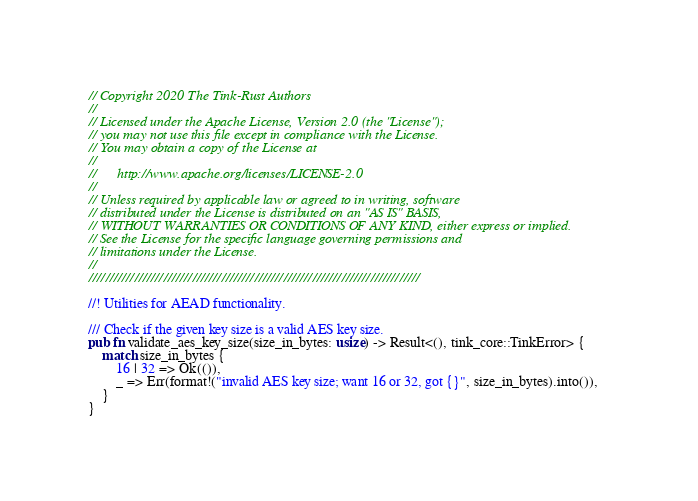<code> <loc_0><loc_0><loc_500><loc_500><_Rust_>// Copyright 2020 The Tink-Rust Authors
//
// Licensed under the Apache License, Version 2.0 (the "License");
// you may not use this file except in compliance with the License.
// You may obtain a copy of the License at
//
//      http://www.apache.org/licenses/LICENSE-2.0
//
// Unless required by applicable law or agreed to in writing, software
// distributed under the License is distributed on an "AS IS" BASIS,
// WITHOUT WARRANTIES OR CONDITIONS OF ANY KIND, either express or implied.
// See the License for the specific language governing permissions and
// limitations under the License.
//
////////////////////////////////////////////////////////////////////////////////

//! Utilities for AEAD functionality.

/// Check if the given key size is a valid AES key size.
pub fn validate_aes_key_size(size_in_bytes: usize) -> Result<(), tink_core::TinkError> {
    match size_in_bytes {
        16 | 32 => Ok(()),
        _ => Err(format!("invalid AES key size; want 16 or 32, got {}", size_in_bytes).into()),
    }
}
</code> 